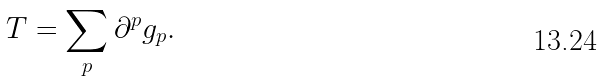<formula> <loc_0><loc_0><loc_500><loc_500>T = \sum _ { p } \partial ^ { p } g _ { p } .</formula> 